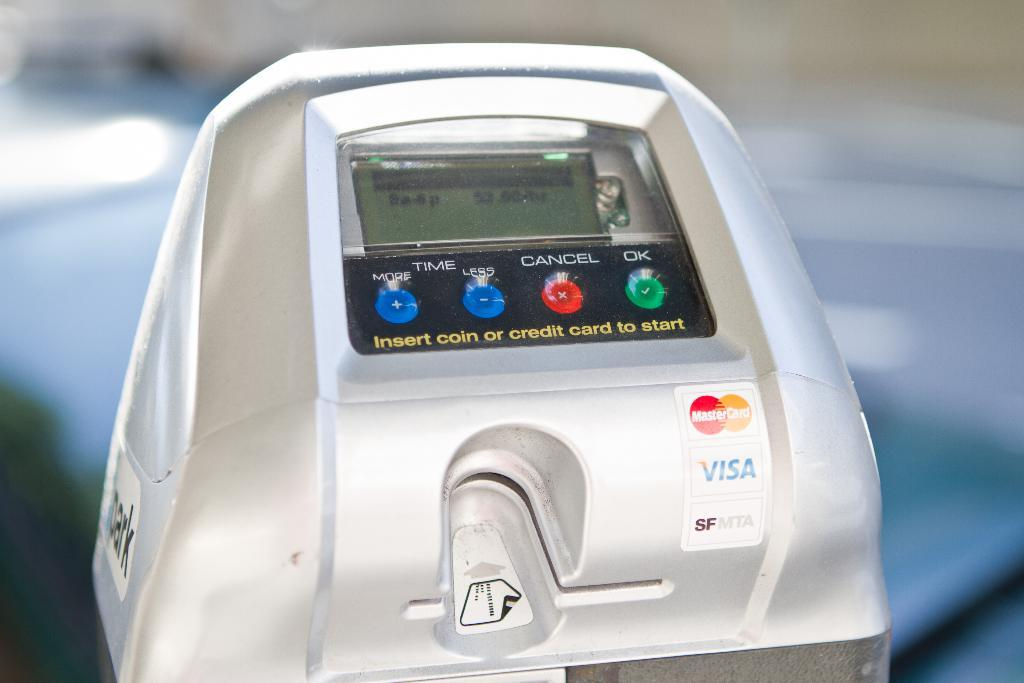Provide a one-sentence caption for the provided image. a machine that accepts both MasterCard and Visa. 